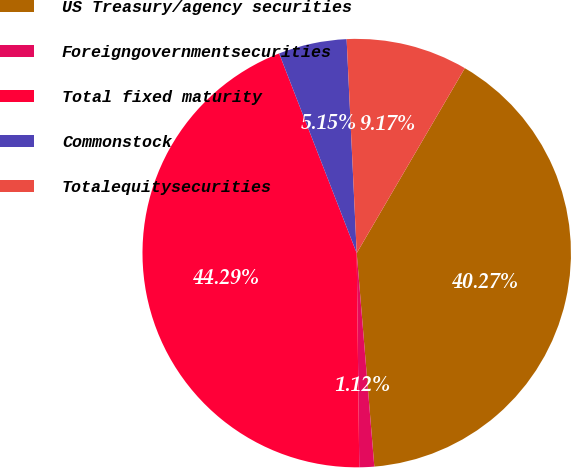<chart> <loc_0><loc_0><loc_500><loc_500><pie_chart><fcel>US Treasury/agency securities<fcel>Foreigngovernmentsecurities<fcel>Total fixed maturity<fcel>Commonstock<fcel>Totalequitysecurities<nl><fcel>40.27%<fcel>1.12%<fcel>44.29%<fcel>5.15%<fcel>9.17%<nl></chart> 